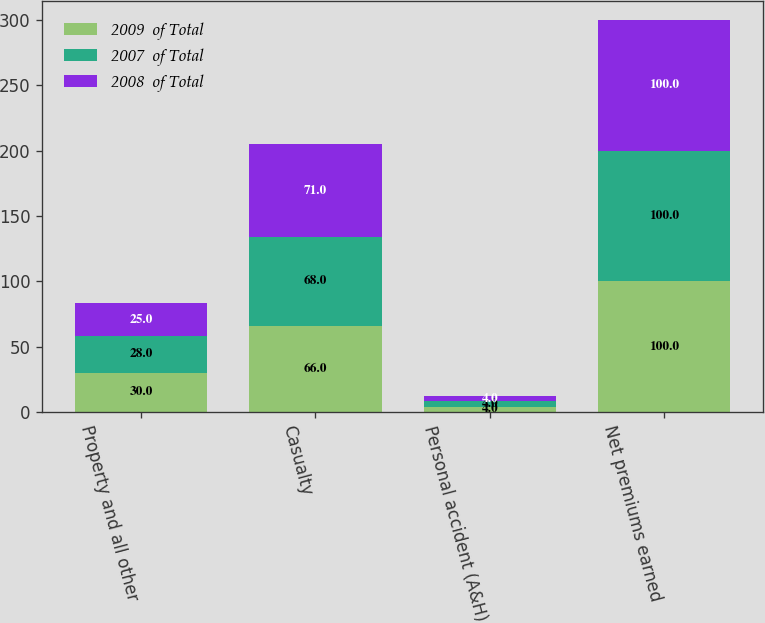Convert chart to OTSL. <chart><loc_0><loc_0><loc_500><loc_500><stacked_bar_chart><ecel><fcel>Property and all other<fcel>Casualty<fcel>Personal accident (A&H)<fcel>Net premiums earned<nl><fcel>2009  of Total<fcel>30<fcel>66<fcel>4<fcel>100<nl><fcel>2007  of Total<fcel>28<fcel>68<fcel>4<fcel>100<nl><fcel>2008  of Total<fcel>25<fcel>71<fcel>4<fcel>100<nl></chart> 